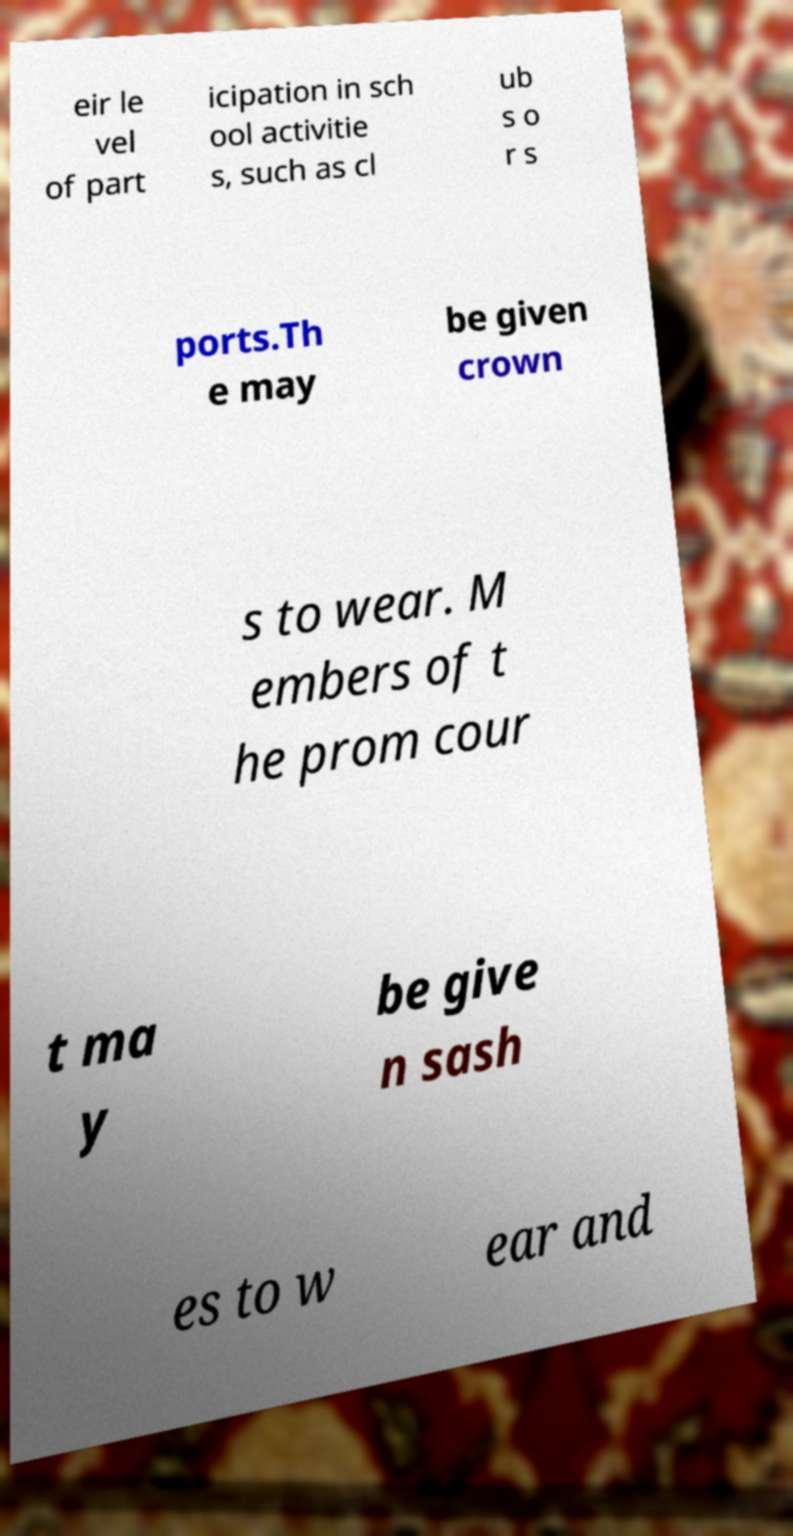Can you accurately transcribe the text from the provided image for me? eir le vel of part icipation in sch ool activitie s, such as cl ub s o r s ports.Th e may be given crown s to wear. M embers of t he prom cour t ma y be give n sash es to w ear and 